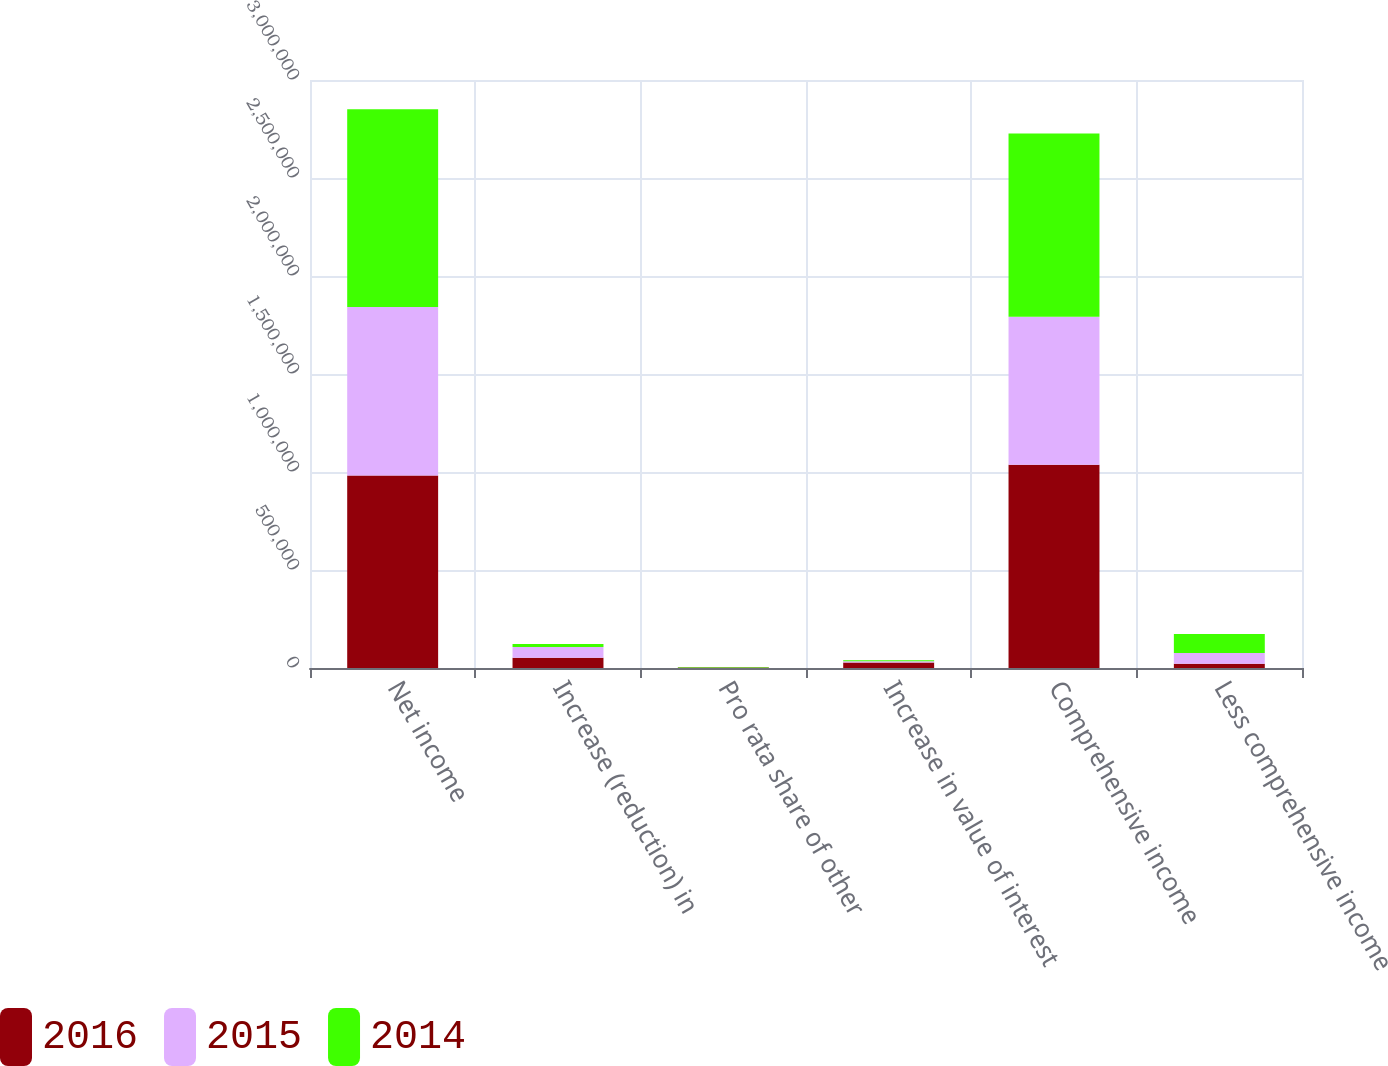Convert chart to OTSL. <chart><loc_0><loc_0><loc_500><loc_500><stacked_bar_chart><ecel><fcel>Net income<fcel>Increase (reduction) in<fcel>Pro rata share of other<fcel>Increase in value of interest<fcel>Comprehensive income<fcel>Less comprehensive income<nl><fcel>2016<fcel>981922<fcel>52057<fcel>2739<fcel>27432<fcel>1.03732e+06<fcel>21351<nl><fcel>2015<fcel>859430<fcel>55326<fcel>327<fcel>6441<fcel>754453<fcel>55765<nl><fcel>2014<fcel>1.00903e+06<fcel>14465<fcel>2509<fcel>6079<fcel>935518<fcel>96561<nl></chart> 